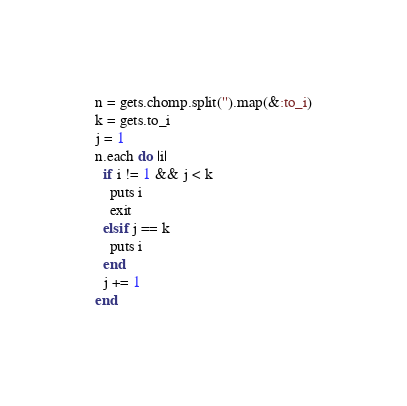<code> <loc_0><loc_0><loc_500><loc_500><_Ruby_>n = gets.chomp.split('').map(&:to_i)
k = gets.to_i
j = 1
n.each do |i|
  if i != 1 && j < k 
    puts i
    exit
  elsif j == k
    puts i
  end
  j += 1
end</code> 